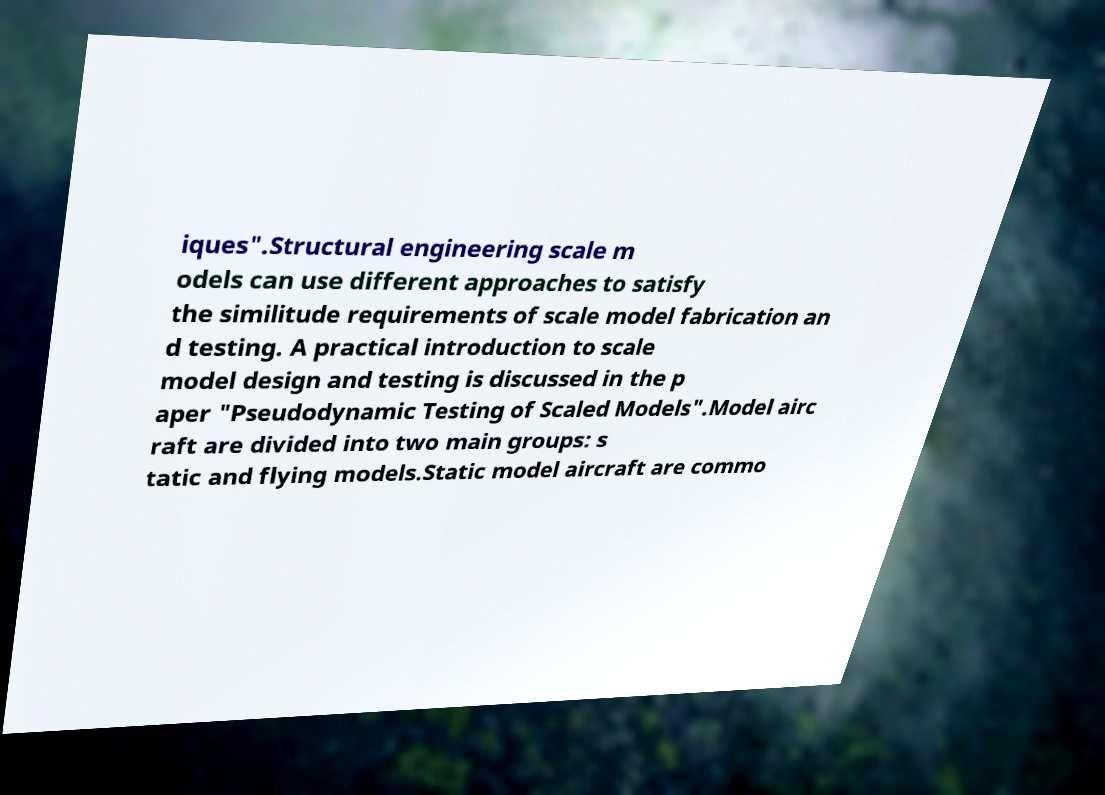For documentation purposes, I need the text within this image transcribed. Could you provide that? iques".Structural engineering scale m odels can use different approaches to satisfy the similitude requirements of scale model fabrication an d testing. A practical introduction to scale model design and testing is discussed in the p aper "Pseudodynamic Testing of Scaled Models".Model airc raft are divided into two main groups: s tatic and flying models.Static model aircraft are commo 